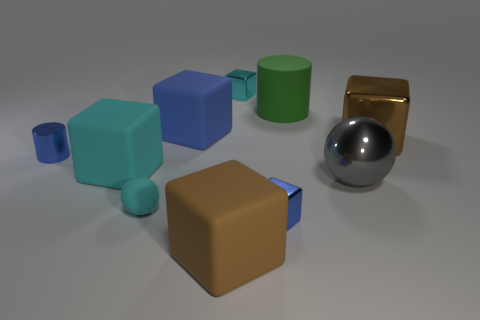Subtract 4 blocks. How many blocks are left? 2 Subtract all blue metallic cubes. How many cubes are left? 5 Subtract all blue blocks. How many blocks are left? 4 Subtract all yellow blocks. Subtract all brown cylinders. How many blocks are left? 6 Subtract all spheres. How many objects are left? 8 Subtract all large gray balls. Subtract all large objects. How many objects are left? 3 Add 6 green things. How many green things are left? 7 Add 5 big blue rubber blocks. How many big blue rubber blocks exist? 6 Subtract 0 gray cubes. How many objects are left? 10 